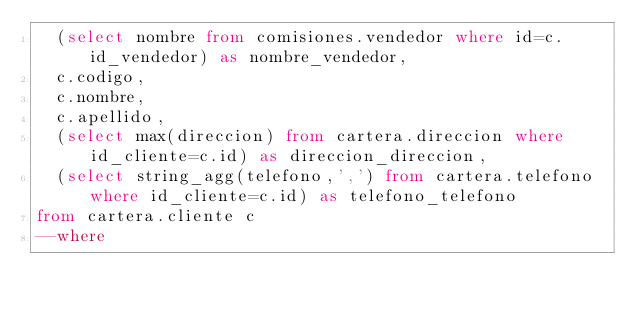<code> <loc_0><loc_0><loc_500><loc_500><_SQL_>	(select nombre from comisiones.vendedor where id=c.id_vendedor) as nombre_vendedor,
	c.codigo,
	c.nombre,
	c.apellido,
	(select max(direccion) from cartera.direccion where id_cliente=c.id) as direccion_direccion,
	(select string_agg(telefono,',') from cartera.telefono where id_cliente=c.id) as telefono_telefono
from cartera.cliente c
--where</code> 